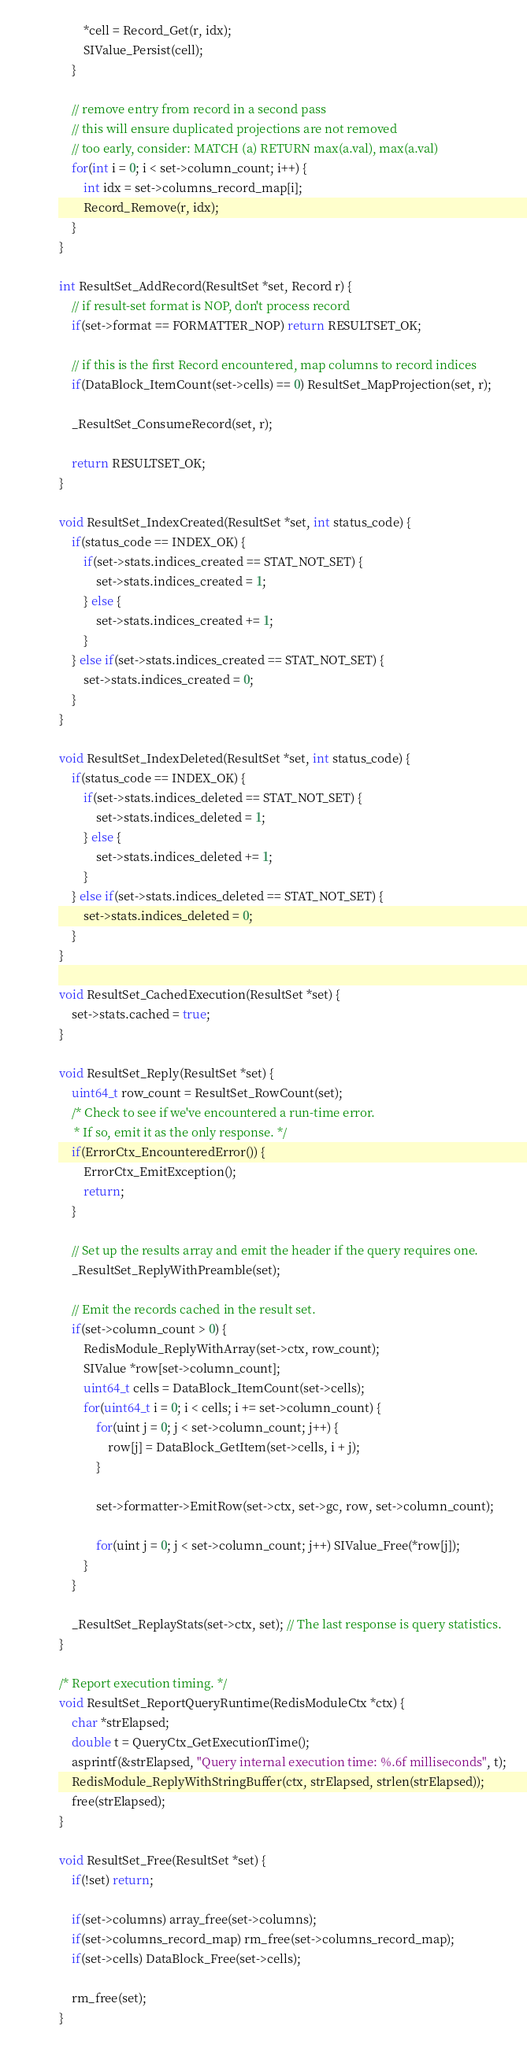Convert code to text. <code><loc_0><loc_0><loc_500><loc_500><_C_>		*cell = Record_Get(r, idx);
		SIValue_Persist(cell);
	}

	// remove entry from record in a second pass
	// this will ensure duplicated projections are not removed
	// too early, consider: MATCH (a) RETURN max(a.val), max(a.val)
	for(int i = 0; i < set->column_count; i++) {
		int idx = set->columns_record_map[i];
		Record_Remove(r, idx);
	}
}

int ResultSet_AddRecord(ResultSet *set, Record r) {
	// if result-set format is NOP, don't process record
	if(set->format == FORMATTER_NOP) return RESULTSET_OK;

	// if this is the first Record encountered, map columns to record indices
	if(DataBlock_ItemCount(set->cells) == 0) ResultSet_MapProjection(set, r);

	_ResultSet_ConsumeRecord(set, r);

	return RESULTSET_OK;
}

void ResultSet_IndexCreated(ResultSet *set, int status_code) {
	if(status_code == INDEX_OK) {
		if(set->stats.indices_created == STAT_NOT_SET) {
			set->stats.indices_created = 1;
		} else {
			set->stats.indices_created += 1;
		}
	} else if(set->stats.indices_created == STAT_NOT_SET) {
		set->stats.indices_created = 0;
	}
}

void ResultSet_IndexDeleted(ResultSet *set, int status_code) {
	if(status_code == INDEX_OK) {
		if(set->stats.indices_deleted == STAT_NOT_SET) {
			set->stats.indices_deleted = 1;
		} else {
			set->stats.indices_deleted += 1;
		}
	} else if(set->stats.indices_deleted == STAT_NOT_SET) {
		set->stats.indices_deleted = 0;
	}
}

void ResultSet_CachedExecution(ResultSet *set) {
	set->stats.cached = true;
}

void ResultSet_Reply(ResultSet *set) {
	uint64_t row_count = ResultSet_RowCount(set);
	/* Check to see if we've encountered a run-time error.
	 * If so, emit it as the only response. */
	if(ErrorCtx_EncounteredError()) {
		ErrorCtx_EmitException();
		return;
	}

	// Set up the results array and emit the header if the query requires one.
	_ResultSet_ReplyWithPreamble(set);

	// Emit the records cached in the result set.
	if(set->column_count > 0) {
		RedisModule_ReplyWithArray(set->ctx, row_count);
		SIValue *row[set->column_count];
		uint64_t cells = DataBlock_ItemCount(set->cells);
		for(uint64_t i = 0; i < cells; i += set->column_count) {
			for(uint j = 0; j < set->column_count; j++) {
				row[j] = DataBlock_GetItem(set->cells, i + j);
			}

			set->formatter->EmitRow(set->ctx, set->gc, row, set->column_count);

			for(uint j = 0; j < set->column_count; j++) SIValue_Free(*row[j]);
		}
	}

	_ResultSet_ReplayStats(set->ctx, set); // The last response is query statistics.
}

/* Report execution timing. */
void ResultSet_ReportQueryRuntime(RedisModuleCtx *ctx) {
	char *strElapsed;
	double t = QueryCtx_GetExecutionTime();
	asprintf(&strElapsed, "Query internal execution time: %.6f milliseconds", t);
	RedisModule_ReplyWithStringBuffer(ctx, strElapsed, strlen(strElapsed));
	free(strElapsed);
}

void ResultSet_Free(ResultSet *set) {
	if(!set) return;

	if(set->columns) array_free(set->columns);
	if(set->columns_record_map) rm_free(set->columns_record_map);
	if(set->cells) DataBlock_Free(set->cells);

	rm_free(set);
}

</code> 